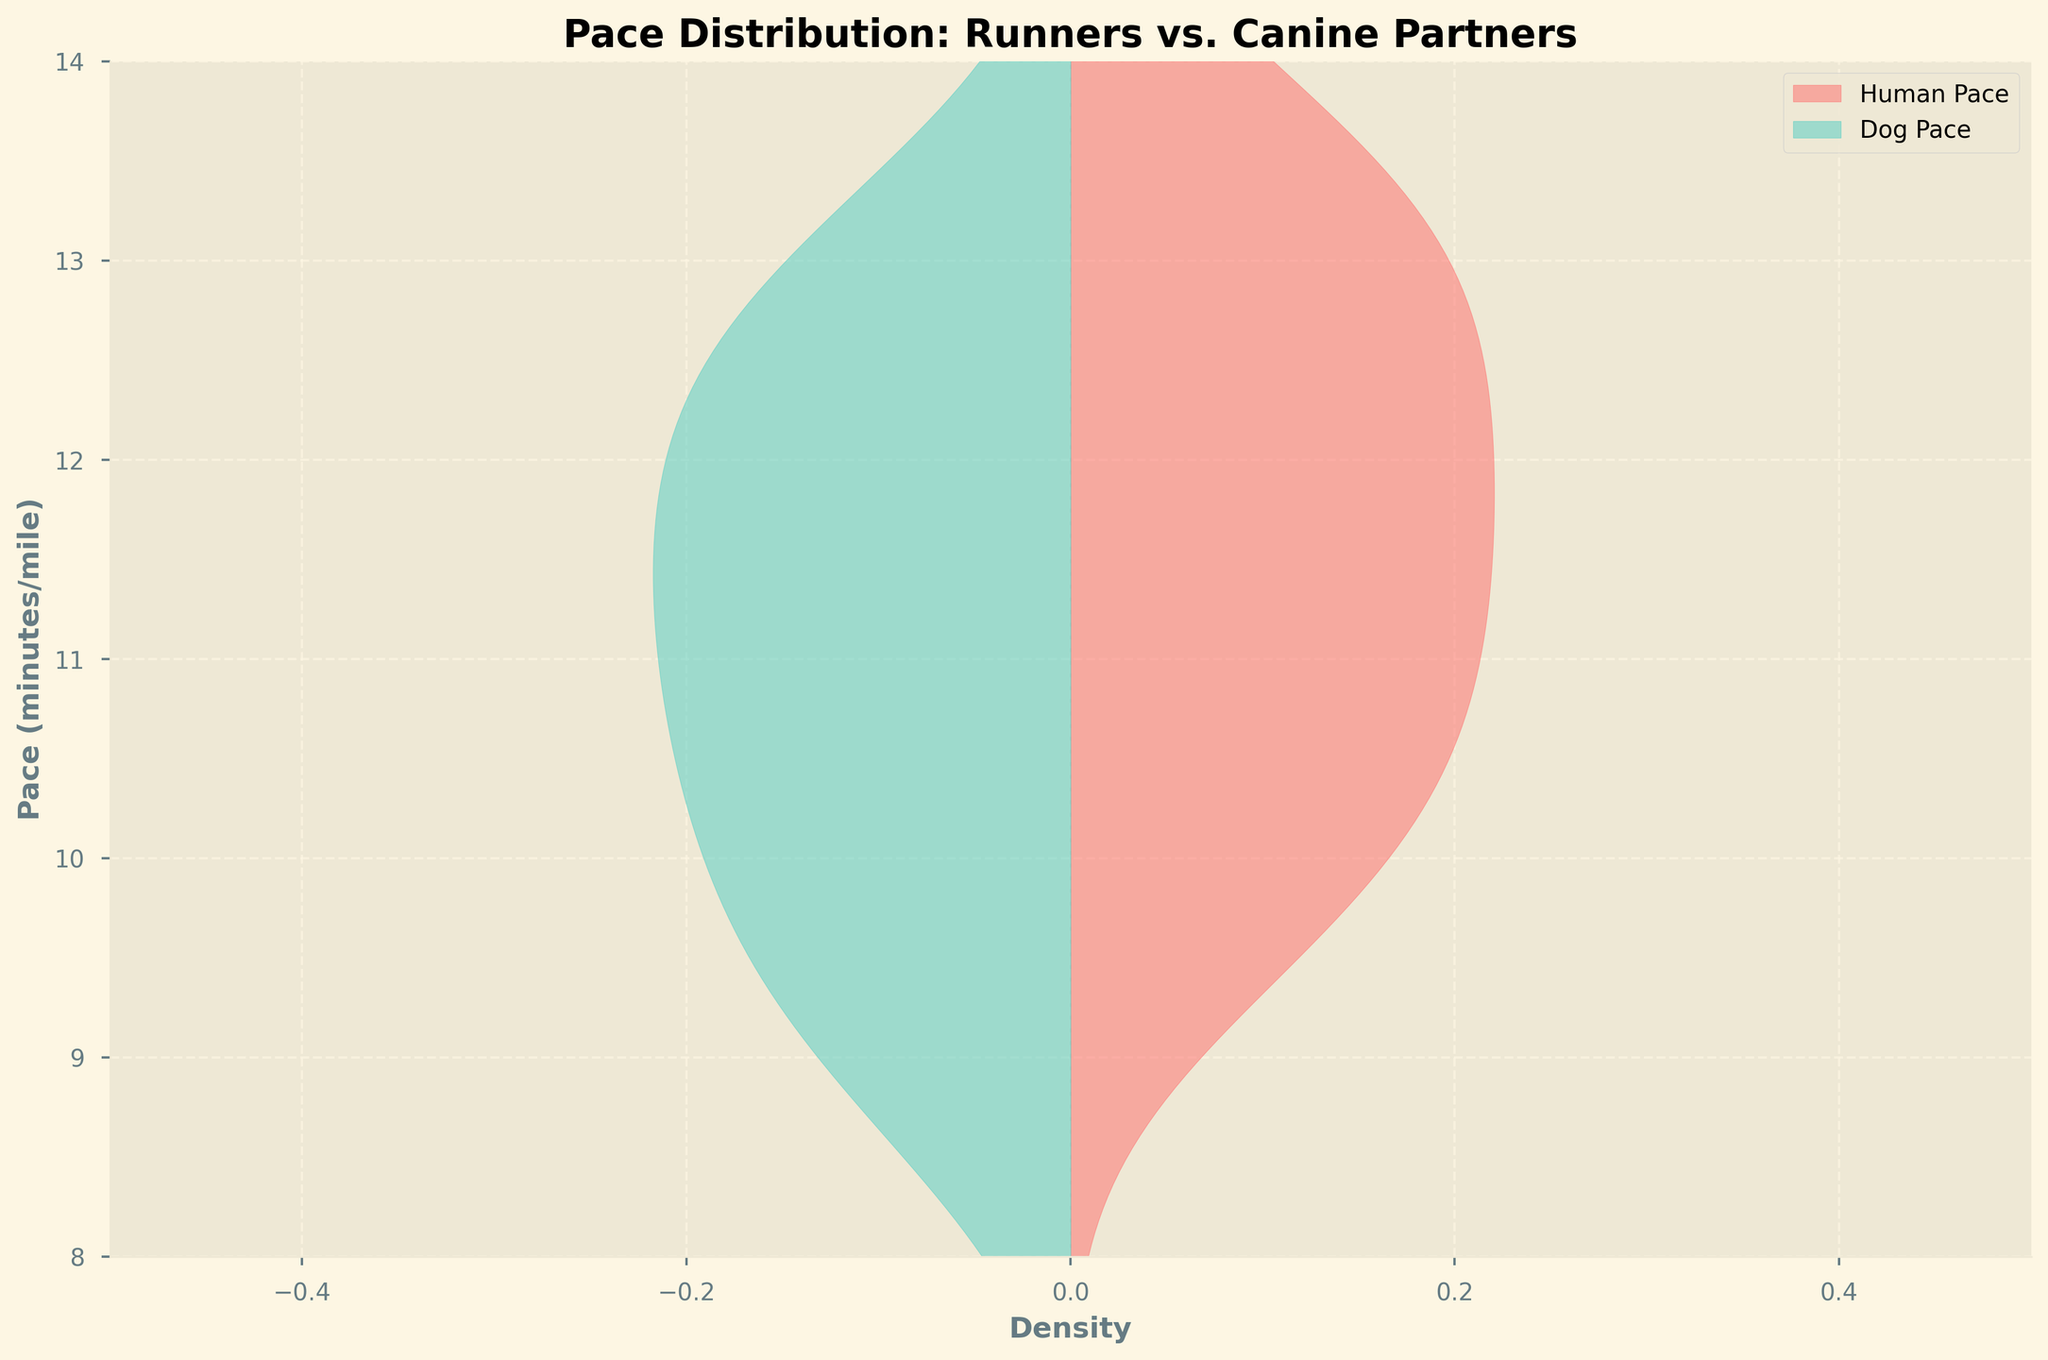What is the title of the figure? The title of the figure is usually placed at the top of the plot. In this case, the title is clearly visible and reads: "Pace Distribution: Runners vs. Canine Partners".
Answer: Pace Distribution: Runners vs. Canine Partners What is the range of the pace values displayed on the y-axis? The y-axis represents the pace values in minutes per mile. By examining the y-axis, we can see that it ranges from 8 to 14 minutes per mile.
Answer: 8 to 14 What colors represent the human and dog paces respectively? Two colors are used to differentiate between human and dog paces. By observing the plot, the human pace is represented by a reddish shade while the dog pace is represented by a turquoise shade.
Answer: Red and turquoise Where is the highest density of human pace found on the plot? The highest density of any distribution is indicated by the peak of the filled area. In this case, the highest density of the human pace distribution appears to be around 12 minutes per mile on the y-axis.
Answer: Around 12 minutes per mile Which pace distribution, human or dog, has a wider spread? A wider spread in density indicates a broader range of values. By comparing the spread of the filled areas, we can see that the human pace distribution has a wider spread from around 9.5 to 13.8 minutes per mile, whereas the dog pace distribution is more narrow, primarily between approximately 9 and 13 minutes per mile.
Answer: Human Is there any overlap in the paces of humans and dogs? Overlap in distributions can be seen where the filled areas of both distributions intersect. In this case, there is a significant overlap between the human and dog paces, especially in the middle range around 9.5 to 12.5 minutes per mile.
Answer: Yes What is the approximate density value of dog pace at 10 minutes per mile? To determine the density value, find where the turquoise distribution intersects the line for 10 minutes per mile on the y-axis and note its width. This width, reflected horizontally, is the approximate density. For the dog pace at 10 minutes per mile, this appears around 0.5 density units (since it is above the 0 line by about half).
Answer: Around 0.5 Which type of question fits best with asking how the densities compare at a specific pace value? This is a comparison question. Understanding how densities of different groups compare at a specific value helps us understand how likely occurrences are for each group at that value.
Answer: Comparison At approximately what pace do both humans and dogs have similar density values? To find the pace where humans and dogs have similar densities, look along the y-axis where the filled areas of both distributions are widest of equal heights. This appears around 11.5 minutes per mile.
Answer: Around 11.5 